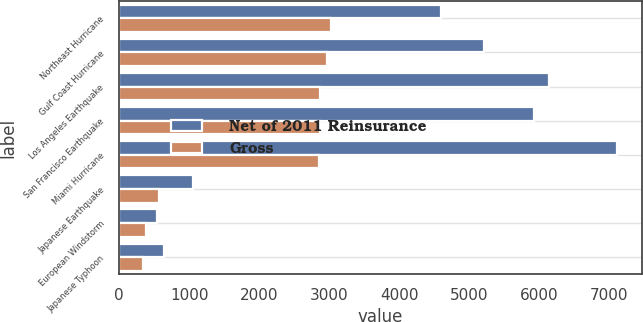Convert chart. <chart><loc_0><loc_0><loc_500><loc_500><stacked_bar_chart><ecel><fcel>Northeast Hurricane<fcel>Gulf Coast Hurricane<fcel>Los Angeles Earthquake<fcel>San Francisco Earthquake<fcel>Miami Hurricane<fcel>Japanese Earthquake<fcel>European Windstorm<fcel>Japanese Typhoon<nl><fcel>Net of 2011 Reinsurance<fcel>4590<fcel>5209<fcel>6140<fcel>5918<fcel>7109<fcel>1052<fcel>545<fcel>641<nl><fcel>Gross<fcel>3024<fcel>2963<fcel>2866<fcel>2864<fcel>2853<fcel>563<fcel>380<fcel>340<nl></chart> 